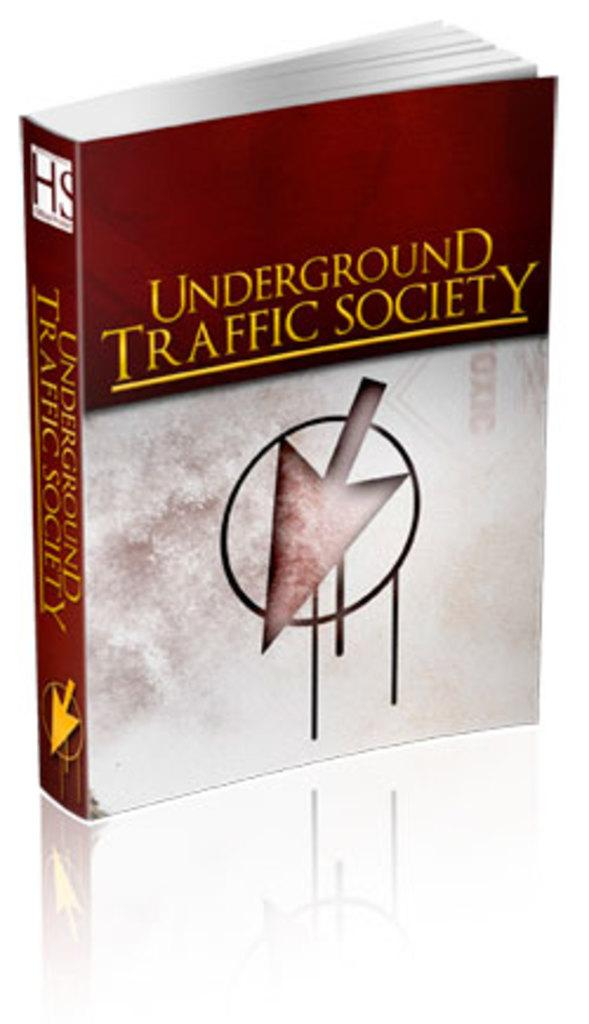<image>
Relay a brief, clear account of the picture shown. A book sitting upright titled Underground Traffic Society. 